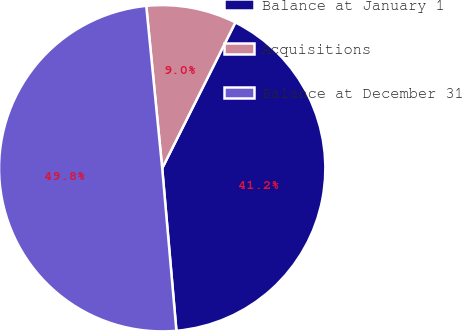<chart> <loc_0><loc_0><loc_500><loc_500><pie_chart><fcel>Balance at January 1<fcel>Acquisitions<fcel>Balance at December 31<nl><fcel>41.21%<fcel>8.96%<fcel>49.83%<nl></chart> 